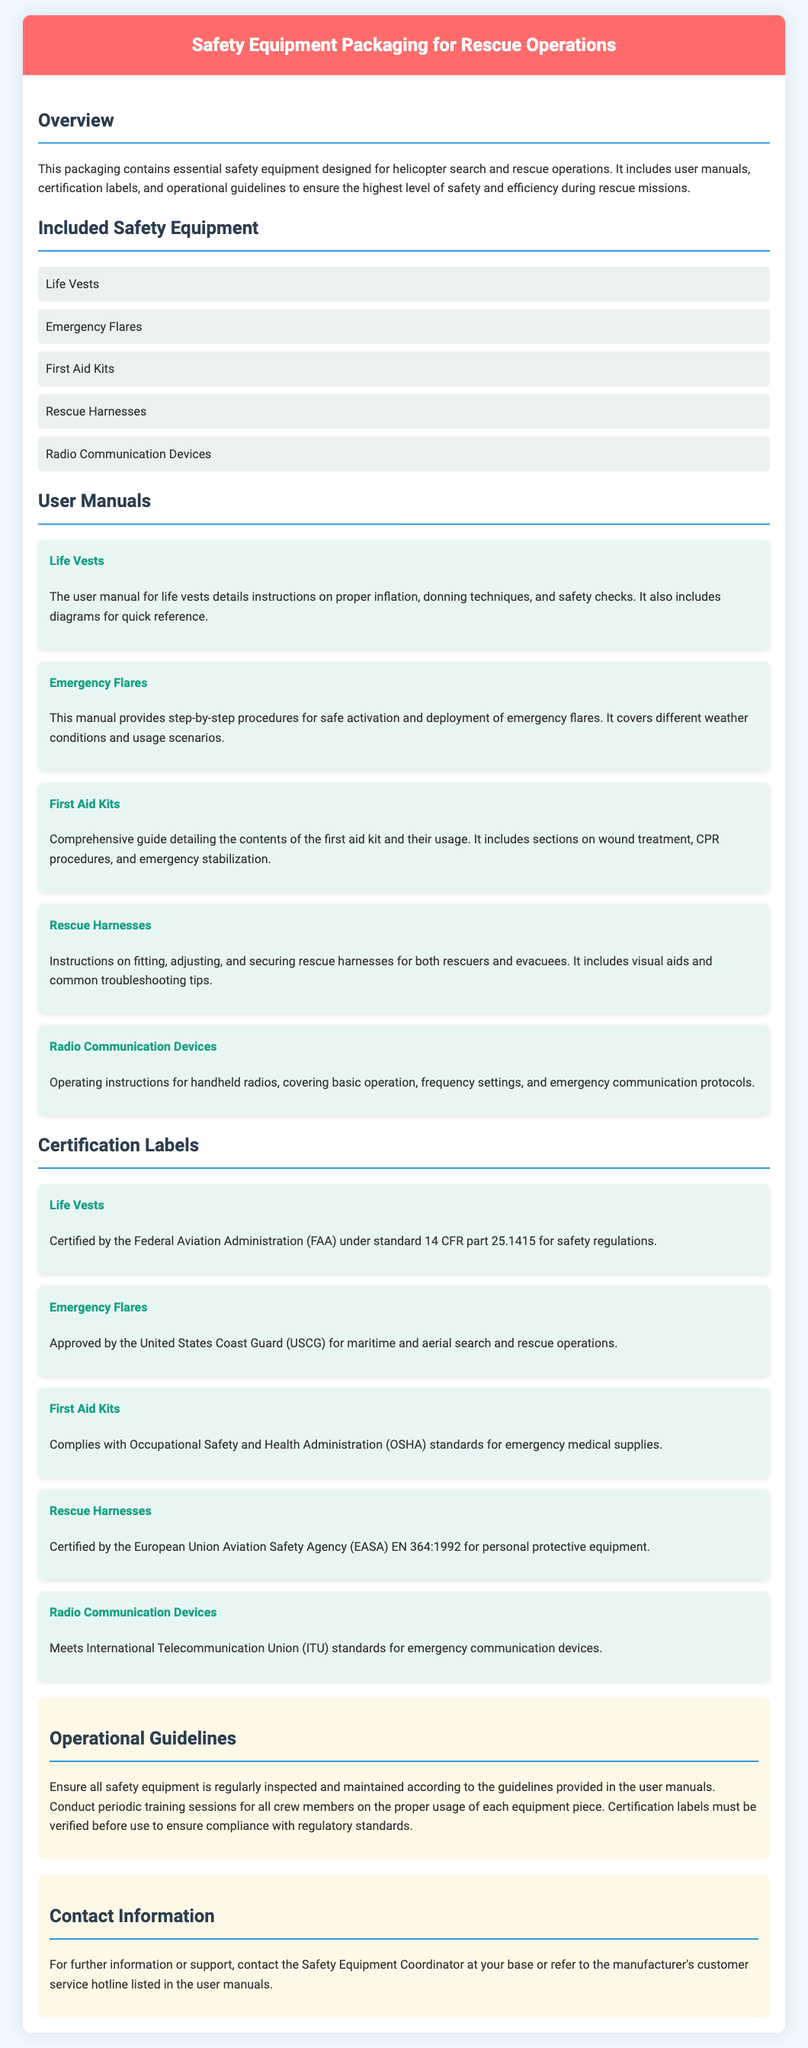what is included in the safety equipment? The safety equipment includes five specific items listed in the document.
Answer: Life Vests, Emergency Flares, First Aid Kits, Rescue Harnesses, Radio Communication Devices which organization certifies the life vests? The certification information is provided in the document under the Certification Labels section.
Answer: Federal Aviation Administration (FAA) how often should equipment be inspected? The operational guidelines mention regular inspection without specifying an exact frequency.
Answer: Regularly what is the purpose of the user manuals? User manuals are intended to provide instructions related to the usage of the safety equipment in rescue operations.
Answer: Instructions what type of certification do emergency flares have? The document specifies the certifying organization and its role in ensuring safety standards for emergency flares.
Answer: Approved by the United States Coast Guard (USCG) how many total user manuals are listed? The document explicitly lists five different user manuals for the safety equipment.
Answer: Five what color is the header of the document? The header color is described in the HTML structure of the document.
Answer: Red who should you contact for further information? The contact information section provides details on who to reach out to for additional support.
Answer: Safety Equipment Coordinator 